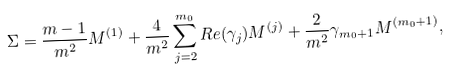Convert formula to latex. <formula><loc_0><loc_0><loc_500><loc_500>\Sigma = \frac { m - 1 } { m ^ { 2 } } M ^ { ( 1 ) } + \frac { 4 } { m ^ { 2 } } \sum _ { j = 2 } ^ { m _ { 0 } } R e ( \gamma _ { j } ) M ^ { ( j ) } + \frac { 2 } { m ^ { 2 } } \gamma _ { m _ { 0 } + 1 } M ^ { ( m _ { 0 } + 1 ) } ,</formula> 